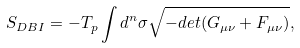<formula> <loc_0><loc_0><loc_500><loc_500>S _ { D B I } = - T _ { p } \int d ^ { n } \sigma \sqrt { - d e t ( G _ { \mu \nu } + F _ { \mu \nu } ) } ,</formula> 